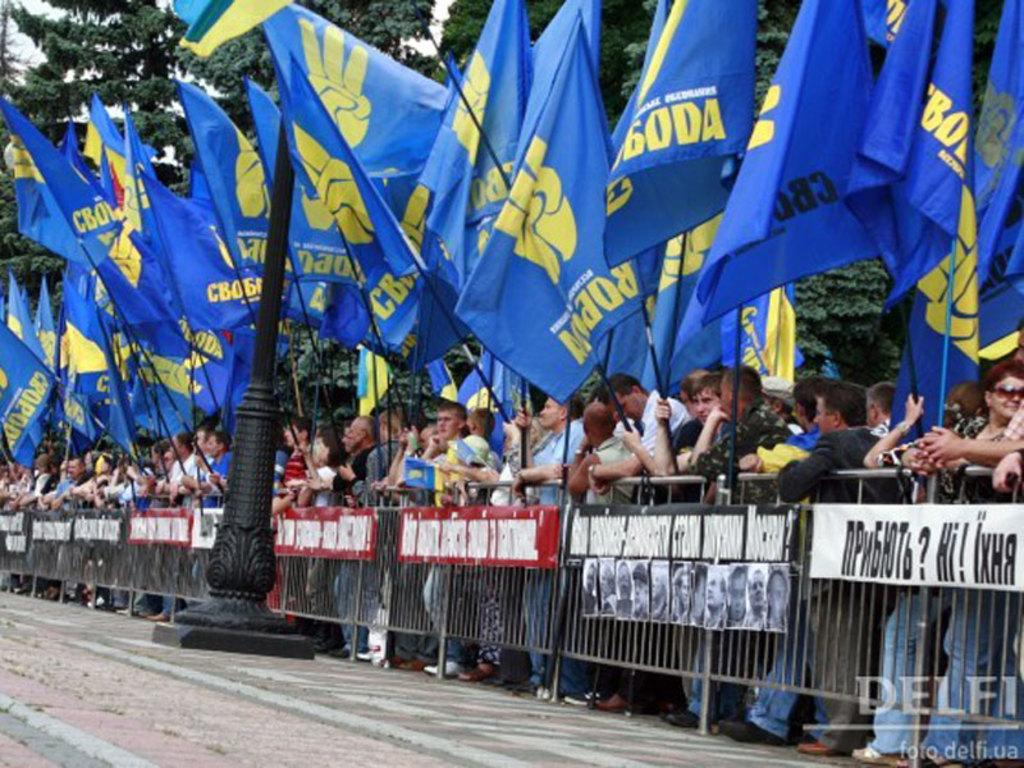What are the people in the image doing? The people in the image are standing and holding flags. What can be seen in the background of the image? There are trees visible in the image. What type of fencing is present in the image? Iron fencing is visible in the image. What type of vest is the person wearing in the image? There is no vest visible in the image; the people are holding flags. What appliance can be seen on the ground in the image? There is no appliance present in the image; it features people holding flags and iron fencing. 